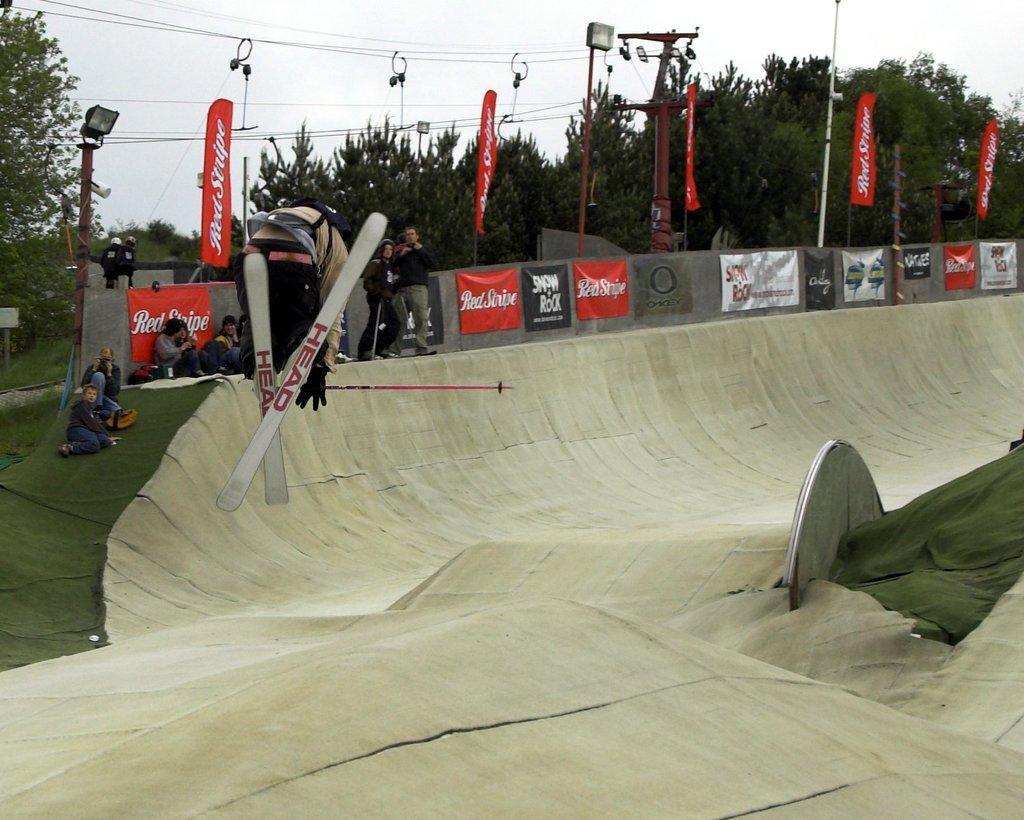In one or two sentences, can you explain what this image depicts? In this image, there are a few people. Among them, we can see a person skating. We can see the ground with some objects. We can see the fence with some banners. There are a few poles with lights and wires. We can also see some flags with text. There are a few trees. We can see the sky. 